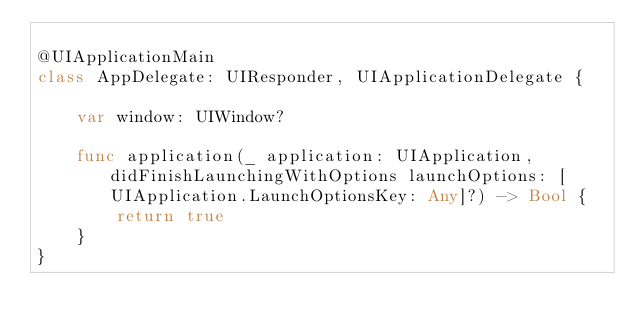<code> <loc_0><loc_0><loc_500><loc_500><_Swift_>
@UIApplicationMain
class AppDelegate: UIResponder, UIApplicationDelegate {

    var window: UIWindow?

    func application(_ application: UIApplication, didFinishLaunchingWithOptions launchOptions: [UIApplication.LaunchOptionsKey: Any]?) -> Bool {
        return true
    }
}

</code> 